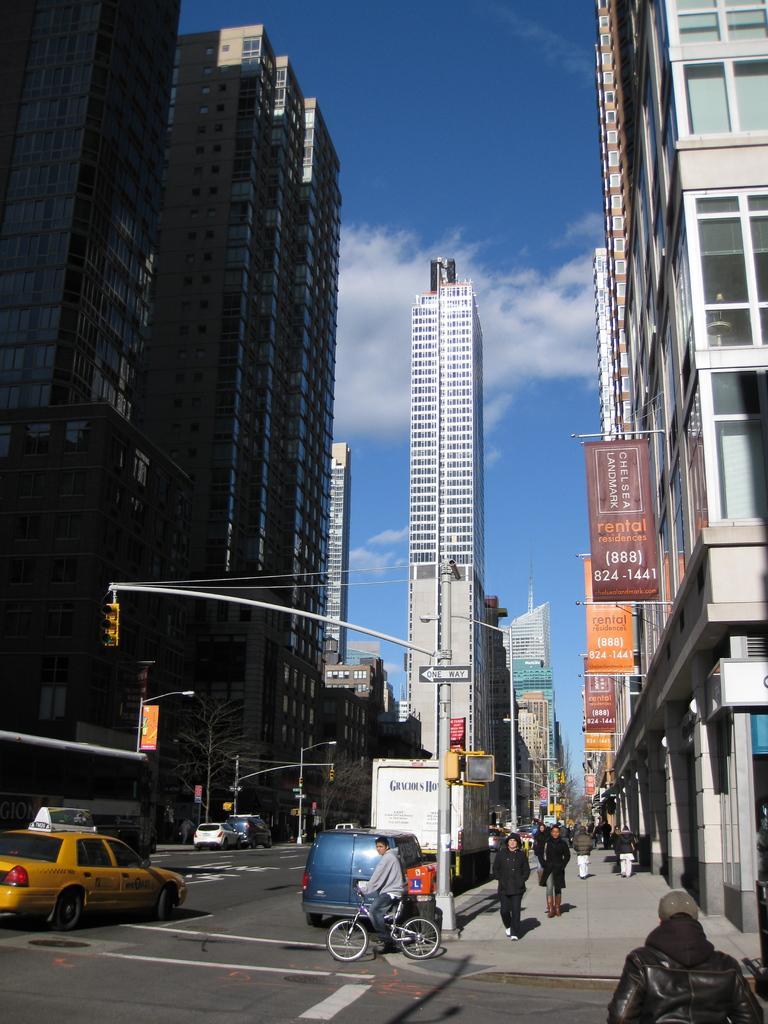Can you describe this image briefly? In this image I can see the road, few vehicles on the road, the sidewalk, the person standing on the side walk, few poles, a traffic signal, a tree, few banners and few buildings on both sides of the road. In the background I can see the sky. 